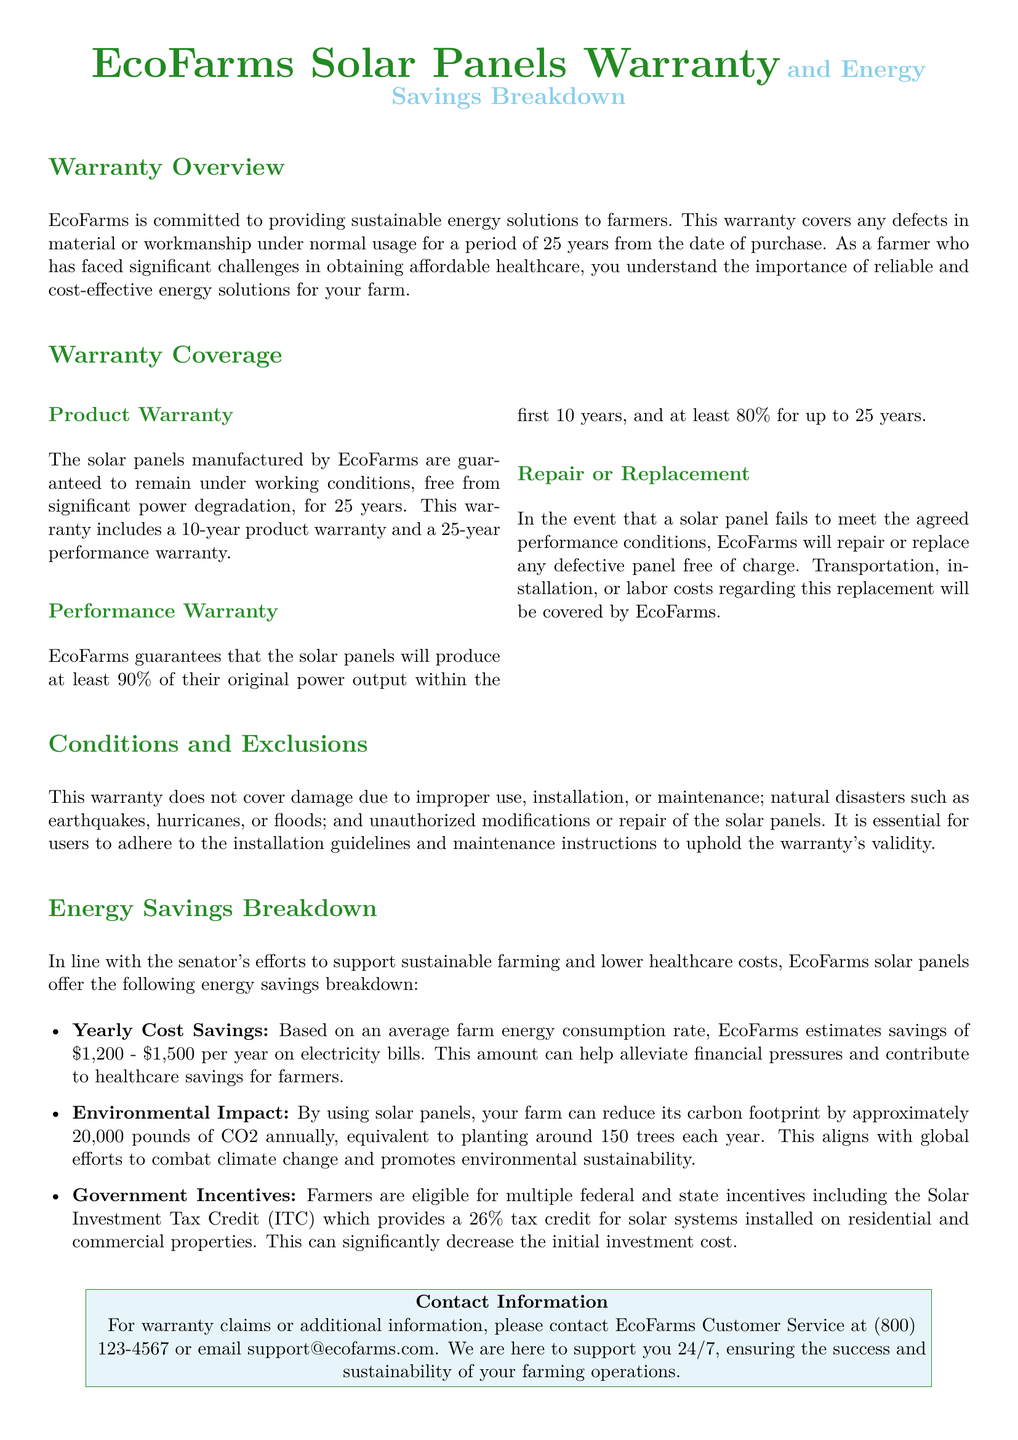What is the warranty period for the solar panels? The warranty period covers defects in material or workmanship under normal usage for a period of 25 years from the date of purchase.
Answer: 25 years What percentage of the original power output do the solar panels ensure within the first 10 years? EcoFarms guarantees that the solar panels will produce at least 90% of their original power output within the first 10 years.
Answer: 90% What is the estimated yearly cost savings for farmers using EcoFarms solar panels? Based on an average farm energy consumption rate, EcoFarms estimates savings of $1,200 - $1,500 per year on electricity bills.
Answer: $1,200 - $1,500 What does the warranty not cover? The warranty does not cover damage due to improper use, installation, or maintenance; natural disasters; and unauthorized modifications.
Answer: Improper use How much CO2 reduction does using EcoFarms solar panels provide annually? By using solar panels, your farm can reduce its carbon footprint by approximately 20,000 pounds of CO2 annually.
Answer: 20,000 pounds What is the percentage of the tax credit provided by the Solar Investment Tax Credit? The Solar Investment Tax Credit provides a 26% tax credit for solar systems installed on residential and commercial properties.
Answer: 26% What does EcoFarms provide in case of a performance issue with the solar panels? EcoFarms will repair or replace any defective panel free of charge if the solar panels fail to meet the agreed performance conditions.
Answer: Repair or replace What color is used for the title of the warranty document? The title of the warranty document is colored in farmgreen.
Answer: farmgreen 